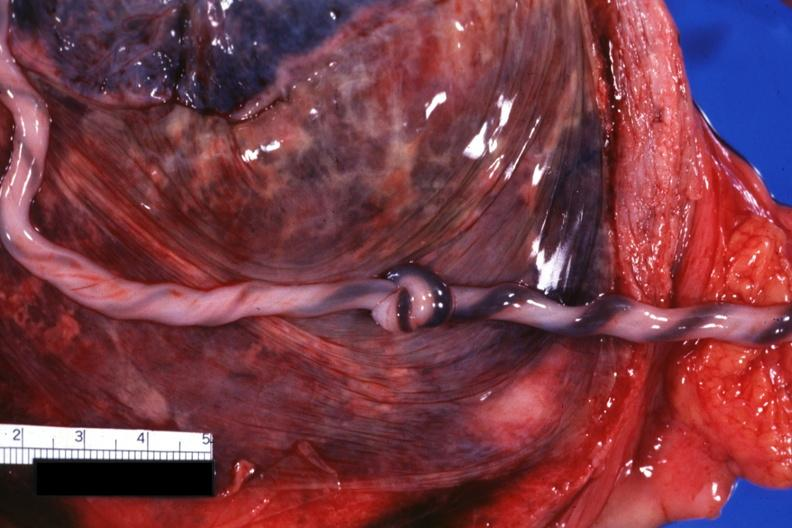does medial aspect show well shown knot?
Answer the question using a single word or phrase. No 